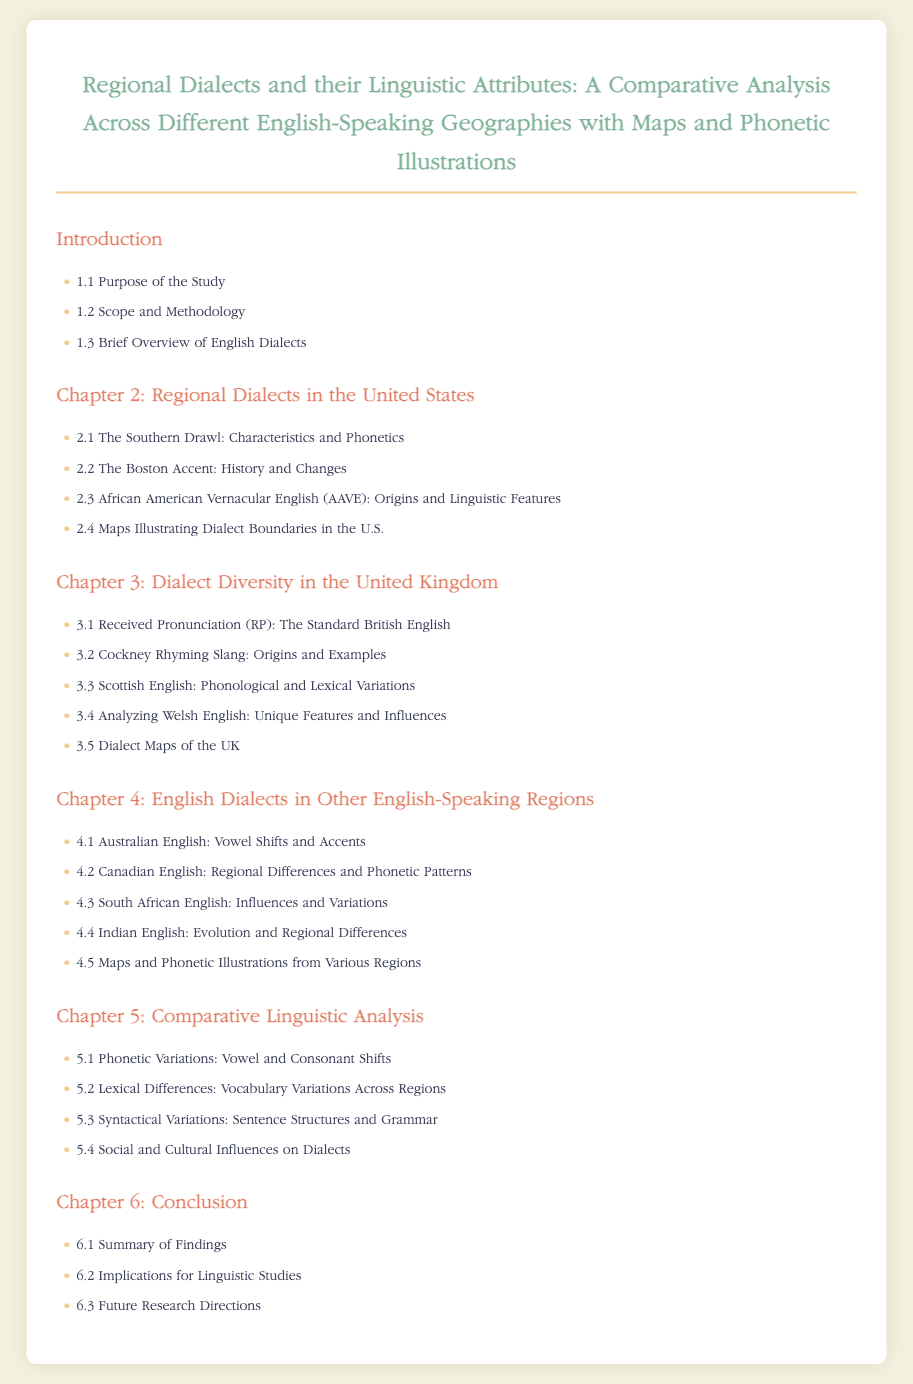What is the title of the document? The title is the main heading that summarizes the content covered in the document.
Answer: Regional Dialects and their Linguistic Attributes: A Comparative Analysis Across Different English-Speaking Geographies with Maps and Phonetic Illustrations How many chapters are in the document? The chapters are outlined in the index section of the document.
Answer: Six What is the focus of Chapter 2? Chapter 2 discusses the regional dialects specific to a certain country, as indicated in the chapter heading.
Answer: Regional Dialects in the United States What unique dialect is analyzed in Chapter 3? Chapter 3 covers a specific dialect found within a particular region of a nation.
Answer: Cockney Rhyming Slang Which English dialect is known for vowel shifts as mentioned in Chapter 4? The specific dialect is highlighted in Chapter 4 with reference to phonetic characteristics.
Answer: Australian English What section discusses social influences on dialects? This section explores how cultural aspects might affect language variations, as mentioned in the index.
Answer: 5.4 Social and Cultural Influences on Dialects What is the main topic of Chapter 5? Chapter 5 looks into comparative aspects of different dialects based on phonetic and lexical features.
Answer: Comparative Linguistic Analysis What is the last subsection of the document? The last subsection summarizes future directions for research in the field of linguistics.
Answer: 6.3 Future Research Directions 